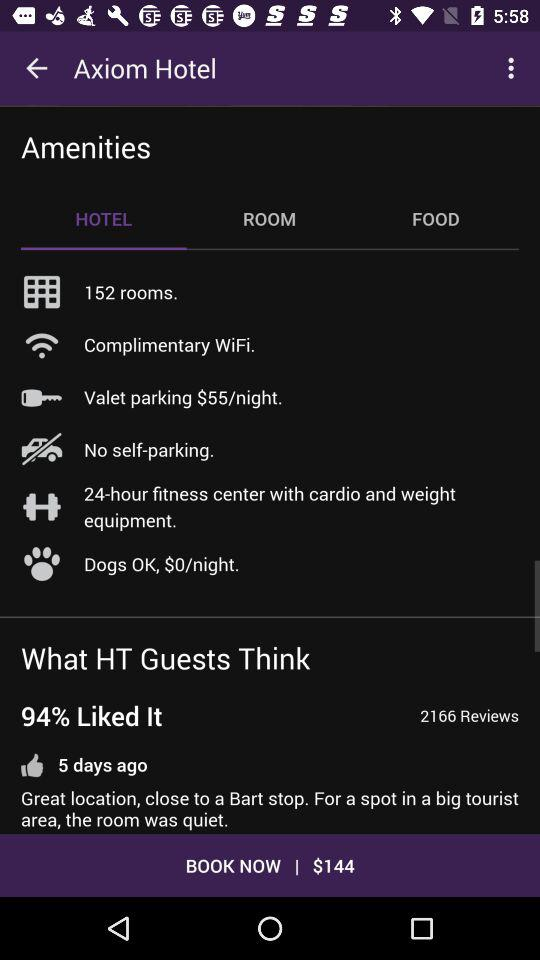What is the booking amount? The booking amount is $144. 